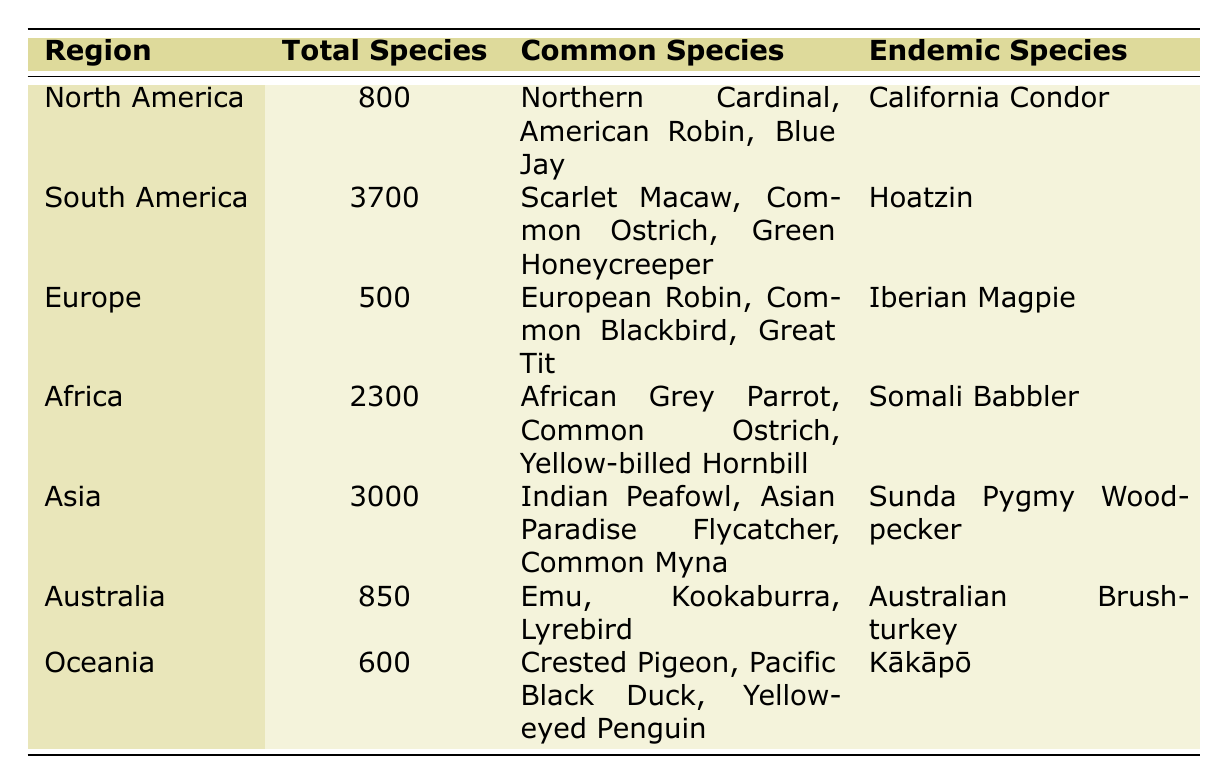What region has the highest total number of bird species? By looking at the "Total Species" column, South America has the highest count at 3700 species, which is greater than all other regions.
Answer: South America Which region has the fewest bird species? The "Total Species" column indicates that Europe has the lowest number of bird species at 500.
Answer: Europe Are there any regions where the common species include the Common Ostrich? Scanning the "Common Species" column shows that the Common Ostrich is listed under both South America and Africa, indicating that it does appear in more than one region.
Answer: Yes What is the total number of bird species in Asia and Africa combined? Adding the total species from Asia (3000) and Africa (2300), we get 3000 + 2300 = 5300.
Answer: 5300 Is there at least one region listed that has an endemic species? Each region includes an endemic species in the "Endemic Species" column, confirming that all regions have at least one endemic bird species.
Answer: Yes Which region features the Australian Brush-turkey as an endemic species? The "Endemic Species" column reveals that the Australian Brush-turkey is listed in the Australia region.
Answer: Australia What is the difference in the total number of bird species between North America and Europe? The total number of species in North America is 800, and in Europe, it is 500. The difference is calculated as 800 - 500 = 300.
Answer: 300 Name a common bird species found in both North America and Africa. The "Common Species" column shows that the Common Ostrich appears in Africa, but it's not listed as a common species in North America. Therefore, there are no common species found in both regions.
Answer: None How many more bird species are found in South America compared to Australia? South America has 3700 species and Australia has 850 species. The difference is 3700 - 850 = 2850, showing that South America has significantly more species than Australia.
Answer: 2850 